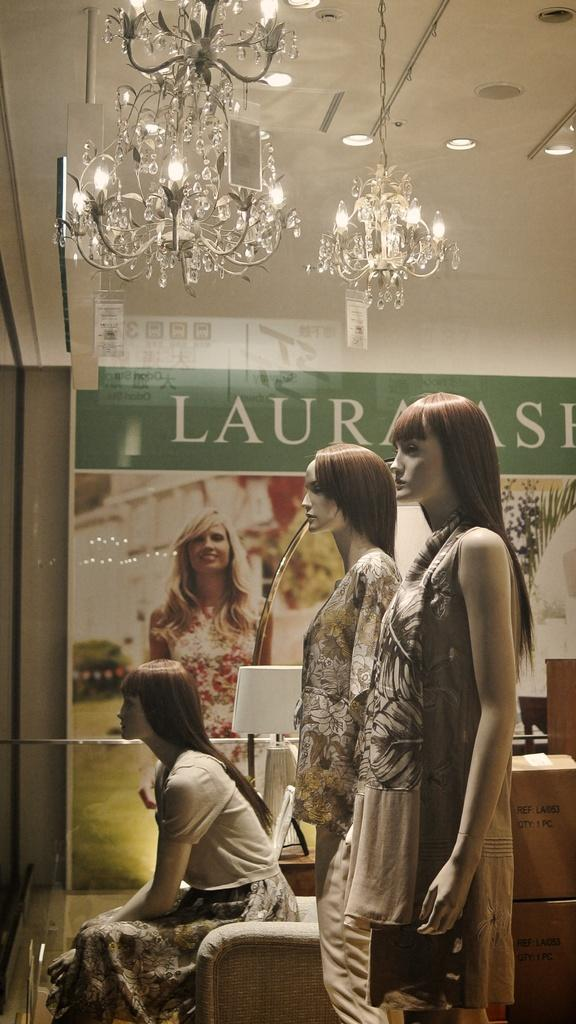What type of figures can be seen in the image? There are mannequins in the image. What can be seen on the wall in the background? There is text written on the wall in the background. What is visible at the top of the image? There are lights visible at the top of the image. How many apples are being held by the mannequins in the image? There are no apples present in the image; the mannequins do not have any objects in their hands. 